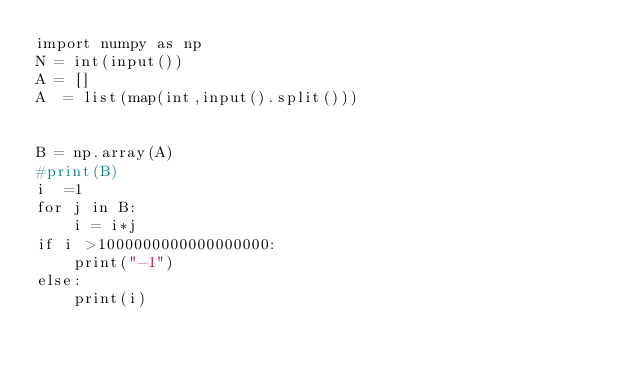Convert code to text. <code><loc_0><loc_0><loc_500><loc_500><_Python_>import numpy as np
N = int(input())
A = []
A  = list(map(int,input().split()))	


B = np.array(A)
#print(B)
i  =1
for j in B:
    i = i*j
if i >1000000000000000000:
    print("-1")
else:
    print(i)</code> 